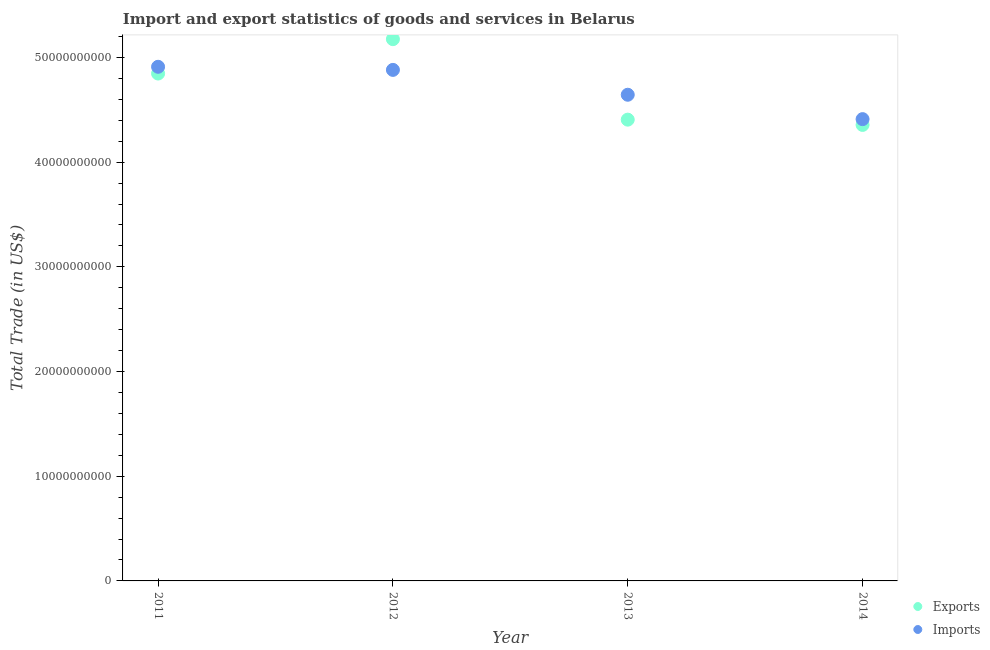How many different coloured dotlines are there?
Provide a succinct answer. 2. What is the export of goods and services in 2012?
Offer a terse response. 5.17e+1. Across all years, what is the maximum imports of goods and services?
Your response must be concise. 4.91e+1. Across all years, what is the minimum imports of goods and services?
Provide a succinct answer. 4.41e+1. What is the total export of goods and services in the graph?
Offer a very short reply. 1.88e+11. What is the difference between the export of goods and services in 2011 and that in 2013?
Offer a very short reply. 4.40e+09. What is the difference between the export of goods and services in 2013 and the imports of goods and services in 2012?
Your response must be concise. -4.75e+09. What is the average imports of goods and services per year?
Ensure brevity in your answer.  4.71e+1. In the year 2012, what is the difference between the imports of goods and services and export of goods and services?
Offer a very short reply. -2.94e+09. In how many years, is the export of goods and services greater than 40000000000 US$?
Keep it short and to the point. 4. What is the ratio of the imports of goods and services in 2011 to that in 2012?
Your answer should be compact. 1.01. Is the imports of goods and services in 2013 less than that in 2014?
Keep it short and to the point. No. Is the difference between the export of goods and services in 2012 and 2014 greater than the difference between the imports of goods and services in 2012 and 2014?
Your answer should be very brief. Yes. What is the difference between the highest and the second highest imports of goods and services?
Provide a succinct answer. 2.96e+08. What is the difference between the highest and the lowest imports of goods and services?
Offer a terse response. 5.00e+09. In how many years, is the export of goods and services greater than the average export of goods and services taken over all years?
Ensure brevity in your answer.  2. Is the sum of the imports of goods and services in 2013 and 2014 greater than the maximum export of goods and services across all years?
Your response must be concise. Yes. Does the imports of goods and services monotonically increase over the years?
Provide a succinct answer. No. Is the export of goods and services strictly less than the imports of goods and services over the years?
Your answer should be very brief. No. Are the values on the major ticks of Y-axis written in scientific E-notation?
Provide a short and direct response. No. Does the graph contain grids?
Provide a short and direct response. No. How many legend labels are there?
Give a very brief answer. 2. What is the title of the graph?
Provide a short and direct response. Import and export statistics of goods and services in Belarus. What is the label or title of the X-axis?
Your answer should be compact. Year. What is the label or title of the Y-axis?
Your answer should be compact. Total Trade (in US$). What is the Total Trade (in US$) of Exports in 2011?
Ensure brevity in your answer.  4.85e+1. What is the Total Trade (in US$) of Imports in 2011?
Offer a very short reply. 4.91e+1. What is the Total Trade (in US$) of Exports in 2012?
Ensure brevity in your answer.  5.17e+1. What is the Total Trade (in US$) of Imports in 2012?
Your answer should be very brief. 4.88e+1. What is the Total Trade (in US$) of Exports in 2013?
Offer a very short reply. 4.41e+1. What is the Total Trade (in US$) of Imports in 2013?
Make the answer very short. 4.64e+1. What is the Total Trade (in US$) of Exports in 2014?
Offer a very short reply. 4.36e+1. What is the Total Trade (in US$) in Imports in 2014?
Provide a succinct answer. 4.41e+1. Across all years, what is the maximum Total Trade (in US$) in Exports?
Ensure brevity in your answer.  5.17e+1. Across all years, what is the maximum Total Trade (in US$) of Imports?
Offer a terse response. 4.91e+1. Across all years, what is the minimum Total Trade (in US$) in Exports?
Ensure brevity in your answer.  4.36e+1. Across all years, what is the minimum Total Trade (in US$) of Imports?
Make the answer very short. 4.41e+1. What is the total Total Trade (in US$) in Exports in the graph?
Your answer should be compact. 1.88e+11. What is the total Total Trade (in US$) of Imports in the graph?
Your response must be concise. 1.88e+11. What is the difference between the Total Trade (in US$) of Exports in 2011 and that in 2012?
Offer a terse response. -3.28e+09. What is the difference between the Total Trade (in US$) in Imports in 2011 and that in 2012?
Keep it short and to the point. 2.96e+08. What is the difference between the Total Trade (in US$) of Exports in 2011 and that in 2013?
Your answer should be compact. 4.40e+09. What is the difference between the Total Trade (in US$) in Imports in 2011 and that in 2013?
Offer a terse response. 2.67e+09. What is the difference between the Total Trade (in US$) in Exports in 2011 and that in 2014?
Provide a short and direct response. 4.91e+09. What is the difference between the Total Trade (in US$) of Imports in 2011 and that in 2014?
Keep it short and to the point. 5.00e+09. What is the difference between the Total Trade (in US$) of Exports in 2012 and that in 2013?
Provide a succinct answer. 7.69e+09. What is the difference between the Total Trade (in US$) in Imports in 2012 and that in 2013?
Offer a terse response. 2.37e+09. What is the difference between the Total Trade (in US$) in Exports in 2012 and that in 2014?
Keep it short and to the point. 8.19e+09. What is the difference between the Total Trade (in US$) in Imports in 2012 and that in 2014?
Give a very brief answer. 4.70e+09. What is the difference between the Total Trade (in US$) of Exports in 2013 and that in 2014?
Provide a succinct answer. 5.03e+08. What is the difference between the Total Trade (in US$) of Imports in 2013 and that in 2014?
Provide a short and direct response. 2.33e+09. What is the difference between the Total Trade (in US$) of Exports in 2011 and the Total Trade (in US$) of Imports in 2012?
Give a very brief answer. -3.48e+08. What is the difference between the Total Trade (in US$) of Exports in 2011 and the Total Trade (in US$) of Imports in 2013?
Your answer should be compact. 2.03e+09. What is the difference between the Total Trade (in US$) of Exports in 2011 and the Total Trade (in US$) of Imports in 2014?
Your answer should be compact. 4.36e+09. What is the difference between the Total Trade (in US$) in Exports in 2012 and the Total Trade (in US$) in Imports in 2013?
Your answer should be compact. 5.31e+09. What is the difference between the Total Trade (in US$) of Exports in 2012 and the Total Trade (in US$) of Imports in 2014?
Offer a terse response. 7.64e+09. What is the difference between the Total Trade (in US$) of Exports in 2013 and the Total Trade (in US$) of Imports in 2014?
Provide a succinct answer. -4.84e+07. What is the average Total Trade (in US$) in Exports per year?
Make the answer very short. 4.70e+1. What is the average Total Trade (in US$) of Imports per year?
Your answer should be compact. 4.71e+1. In the year 2011, what is the difference between the Total Trade (in US$) of Exports and Total Trade (in US$) of Imports?
Your answer should be very brief. -6.45e+08. In the year 2012, what is the difference between the Total Trade (in US$) of Exports and Total Trade (in US$) of Imports?
Provide a succinct answer. 2.94e+09. In the year 2013, what is the difference between the Total Trade (in US$) in Exports and Total Trade (in US$) in Imports?
Your response must be concise. -2.38e+09. In the year 2014, what is the difference between the Total Trade (in US$) of Exports and Total Trade (in US$) of Imports?
Your response must be concise. -5.51e+08. What is the ratio of the Total Trade (in US$) of Exports in 2011 to that in 2012?
Ensure brevity in your answer.  0.94. What is the ratio of the Total Trade (in US$) in Imports in 2011 to that in 2013?
Offer a very short reply. 1.06. What is the ratio of the Total Trade (in US$) in Exports in 2011 to that in 2014?
Ensure brevity in your answer.  1.11. What is the ratio of the Total Trade (in US$) of Imports in 2011 to that in 2014?
Give a very brief answer. 1.11. What is the ratio of the Total Trade (in US$) of Exports in 2012 to that in 2013?
Your answer should be compact. 1.17. What is the ratio of the Total Trade (in US$) in Imports in 2012 to that in 2013?
Give a very brief answer. 1.05. What is the ratio of the Total Trade (in US$) of Exports in 2012 to that in 2014?
Keep it short and to the point. 1.19. What is the ratio of the Total Trade (in US$) in Imports in 2012 to that in 2014?
Make the answer very short. 1.11. What is the ratio of the Total Trade (in US$) in Exports in 2013 to that in 2014?
Offer a terse response. 1.01. What is the ratio of the Total Trade (in US$) of Imports in 2013 to that in 2014?
Offer a very short reply. 1.05. What is the difference between the highest and the second highest Total Trade (in US$) in Exports?
Your answer should be very brief. 3.28e+09. What is the difference between the highest and the second highest Total Trade (in US$) of Imports?
Offer a terse response. 2.96e+08. What is the difference between the highest and the lowest Total Trade (in US$) of Exports?
Make the answer very short. 8.19e+09. What is the difference between the highest and the lowest Total Trade (in US$) of Imports?
Keep it short and to the point. 5.00e+09. 